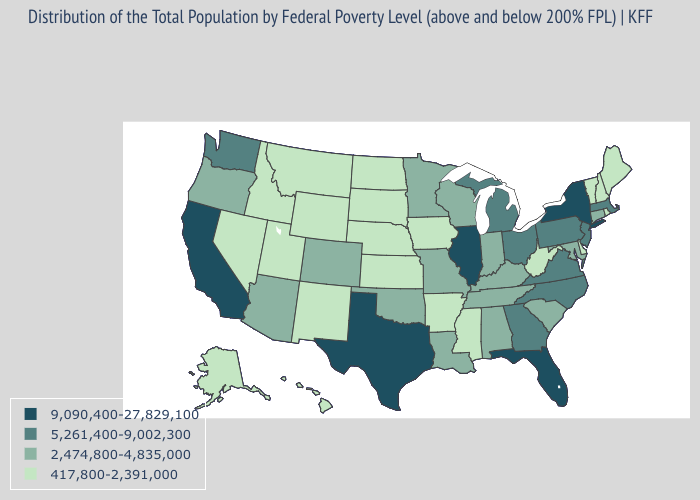Does North Dakota have a lower value than Maryland?
Be succinct. Yes. Does Wyoming have the same value as Maryland?
Keep it brief. No. How many symbols are there in the legend?
Quick response, please. 4. Does Washington have a higher value than Florida?
Concise answer only. No. Name the states that have a value in the range 417,800-2,391,000?
Quick response, please. Alaska, Arkansas, Delaware, Hawaii, Idaho, Iowa, Kansas, Maine, Mississippi, Montana, Nebraska, Nevada, New Hampshire, New Mexico, North Dakota, Rhode Island, South Dakota, Utah, Vermont, West Virginia, Wyoming. How many symbols are there in the legend?
Give a very brief answer. 4. Does North Carolina have a lower value than Illinois?
Keep it brief. Yes. Among the states that border Virginia , does North Carolina have the highest value?
Be succinct. Yes. What is the highest value in states that border Virginia?
Give a very brief answer. 5,261,400-9,002,300. Name the states that have a value in the range 5,261,400-9,002,300?
Quick response, please. Georgia, Massachusetts, Michigan, New Jersey, North Carolina, Ohio, Pennsylvania, Virginia, Washington. Which states have the highest value in the USA?
Short answer required. California, Florida, Illinois, New York, Texas. Does Texas have the highest value in the South?
Give a very brief answer. Yes. Does Illinois have the highest value in the MidWest?
Short answer required. Yes. What is the value of Alabama?
Quick response, please. 2,474,800-4,835,000. What is the lowest value in states that border New Mexico?
Be succinct. 417,800-2,391,000. 